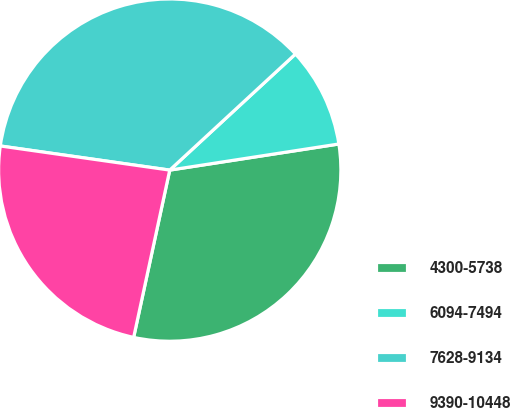<chart> <loc_0><loc_0><loc_500><loc_500><pie_chart><fcel>4300-5738<fcel>6094-7494<fcel>7628-9134<fcel>9390-10448<nl><fcel>30.82%<fcel>9.43%<fcel>35.88%<fcel>23.87%<nl></chart> 